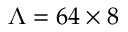Convert formula to latex. <formula><loc_0><loc_0><loc_500><loc_500>\Lambda = 6 4 \times 8</formula> 